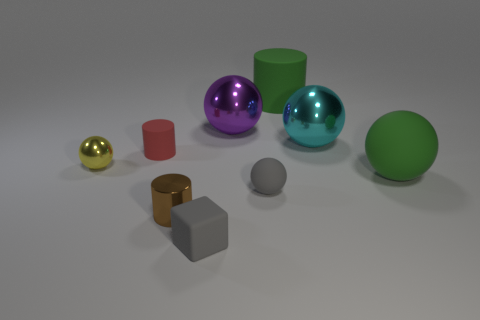Is the red cylinder made of the same material as the tiny sphere that is in front of the yellow shiny sphere?
Your response must be concise. Yes. Is there another red matte object that has the same shape as the tiny red thing?
Your response must be concise. No. There is a gray block that is the same size as the red matte cylinder; what is it made of?
Your response must be concise. Rubber. How big is the gray rubber thing in front of the small matte sphere?
Your response must be concise. Small. Does the matte cylinder that is on the right side of the big purple metal sphere have the same size as the cylinder in front of the green sphere?
Your response must be concise. No. What number of spheres are made of the same material as the big purple thing?
Offer a very short reply. 2. What color is the big rubber cylinder?
Make the answer very short. Green. There is a yellow thing; are there any cyan objects to the left of it?
Provide a short and direct response. No. Does the small cube have the same color as the tiny matte sphere?
Keep it short and to the point. Yes. How many rubber objects have the same color as the tiny block?
Your answer should be compact. 1. 